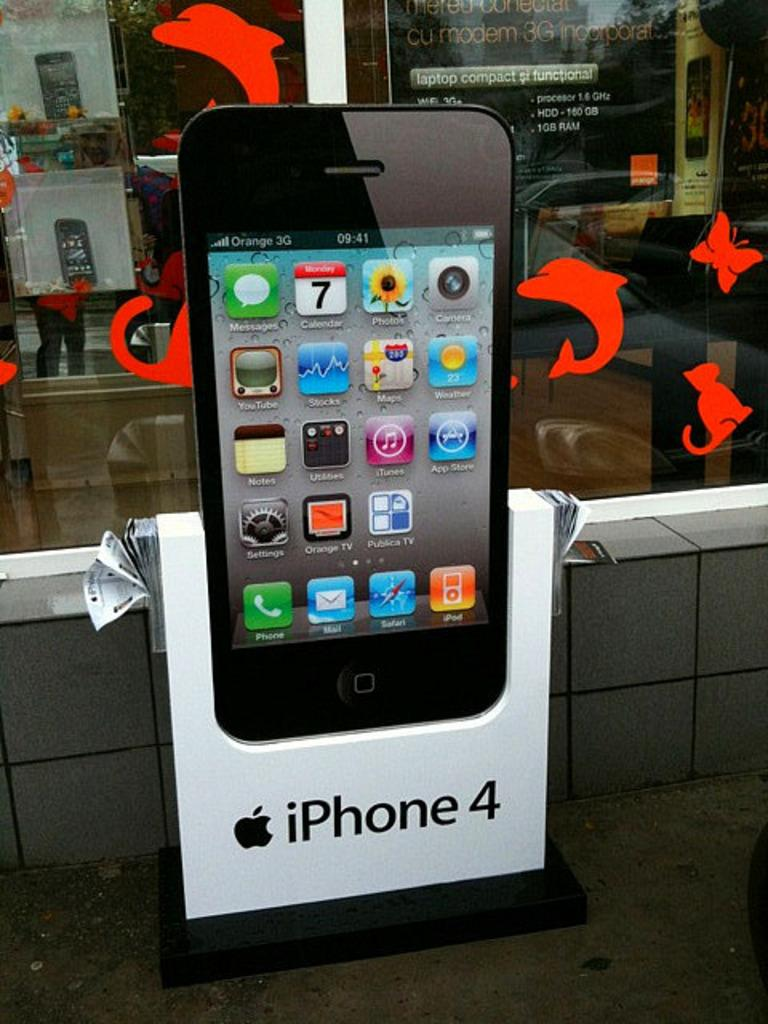<image>
Render a clear and concise summary of the photo. an iPhone ad with a phone in it 